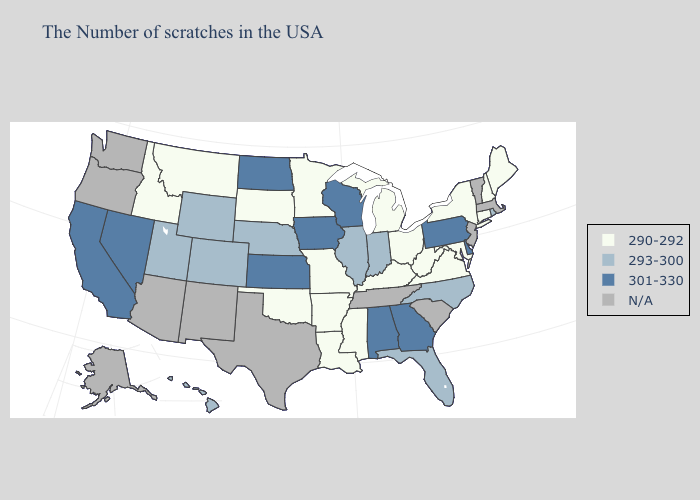Does Mississippi have the lowest value in the USA?
Give a very brief answer. Yes. Name the states that have a value in the range N/A?
Concise answer only. Massachusetts, Vermont, New Jersey, South Carolina, Tennessee, Texas, New Mexico, Arizona, Washington, Oregon, Alaska. Does Rhode Island have the lowest value in the Northeast?
Short answer required. No. What is the value of Washington?
Answer briefly. N/A. What is the value of Maryland?
Answer briefly. 290-292. Which states hav the highest value in the Northeast?
Give a very brief answer. Pennsylvania. Does Hawaii have the lowest value in the West?
Keep it brief. No. What is the value of Utah?
Write a very short answer. 293-300. What is the lowest value in the West?
Quick response, please. 290-292. How many symbols are there in the legend?
Short answer required. 4. Does Florida have the lowest value in the South?
Give a very brief answer. No. What is the value of Maryland?
Be succinct. 290-292. Which states hav the highest value in the Northeast?
Give a very brief answer. Pennsylvania. Does Georgia have the highest value in the South?
Be succinct. Yes. 